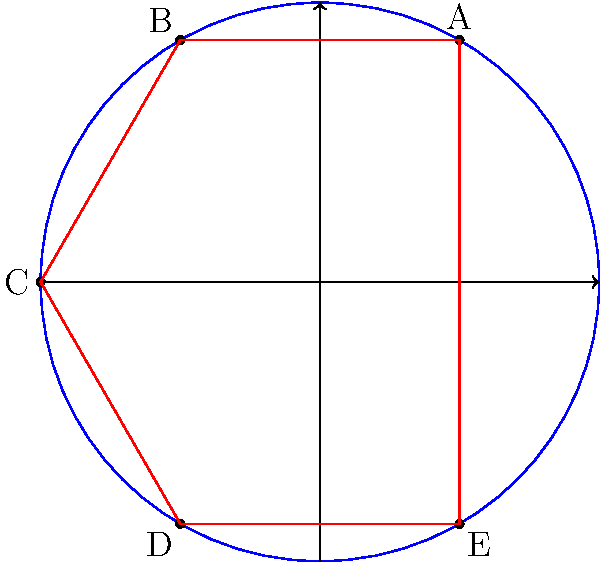In a recent analysis of Michael Gufler's playing style, you've plotted his key positions on a circular field diagram. The positions form a pentagon ABCDE as shown. Given that the field has a radius of 50 meters, calculate the area of the pentagon formed by Gufler's positions. Round your answer to the nearest square meter. To solve this problem, we'll follow these steps:

1) First, we need to recognize that the pentagon is inscribed in a circle with radius 50 meters.

2) The area of a regular pentagon can be calculated using the formula:

   $$A = \frac{5a^2}{4\tan(36°)}$$

   where $a$ is the side length of the pentagon.

3) To find the side length, we can use the formula for the side of a regular polygon inscribed in a circle:

   $$a = 2R \sin(\frac{180°}{n})$$

   where $R$ is the radius of the circle and $n$ is the number of sides.

4) In this case, $R = 50$ and $n = 5$. So:

   $$a = 2 * 50 * \sin(\frac{180°}{5}) = 100 * \sin(36°)$$

5) Now we can substitute this into our area formula:

   $$A = \frac{5(100 * \sin(36°))^2}{4\tan(36°)}$$

6) Simplifying:

   $$A = \frac{50000 * \sin^2(36°)}{\tan(36°)}$$

7) Using a calculator or computer:

   $$A \approx 5857.59 \text{ square meters}$$

8) Rounding to the nearest square meter:

   $$A \approx 5858 \text{ square meters}$$
Answer: 5858 square meters 